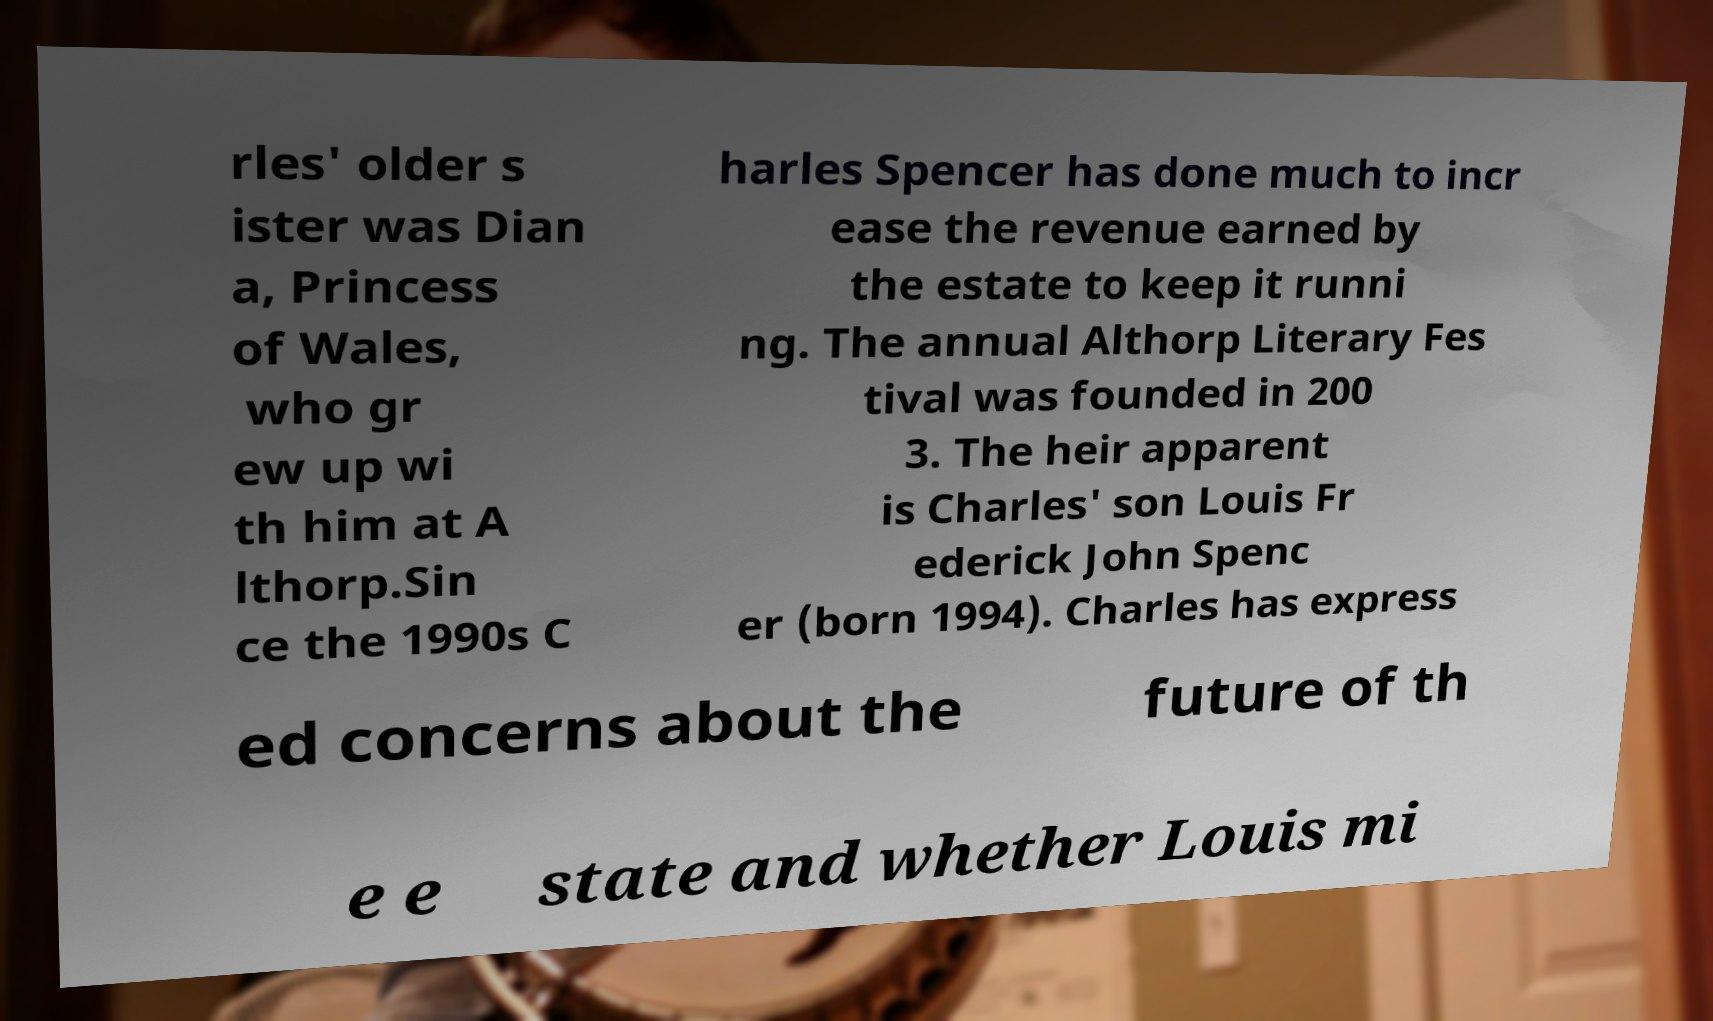Can you accurately transcribe the text from the provided image for me? rles' older s ister was Dian a, Princess of Wales, who gr ew up wi th him at A lthorp.Sin ce the 1990s C harles Spencer has done much to incr ease the revenue earned by the estate to keep it runni ng. The annual Althorp Literary Fes tival was founded in 200 3. The heir apparent is Charles' son Louis Fr ederick John Spenc er (born 1994). Charles has express ed concerns about the future of th e e state and whether Louis mi 